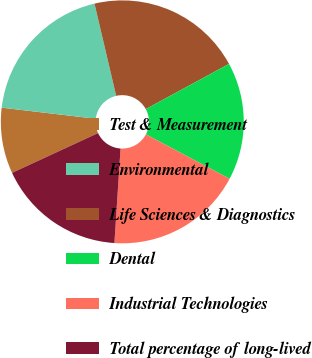Convert chart. <chart><loc_0><loc_0><loc_500><loc_500><pie_chart><fcel>Test & Measurement<fcel>Environmental<fcel>Life Sciences & Diagnostics<fcel>Dental<fcel>Industrial Technologies<fcel>Total percentage of long-lived<nl><fcel>8.76%<fcel>19.46%<fcel>20.76%<fcel>15.68%<fcel>18.27%<fcel>17.07%<nl></chart> 